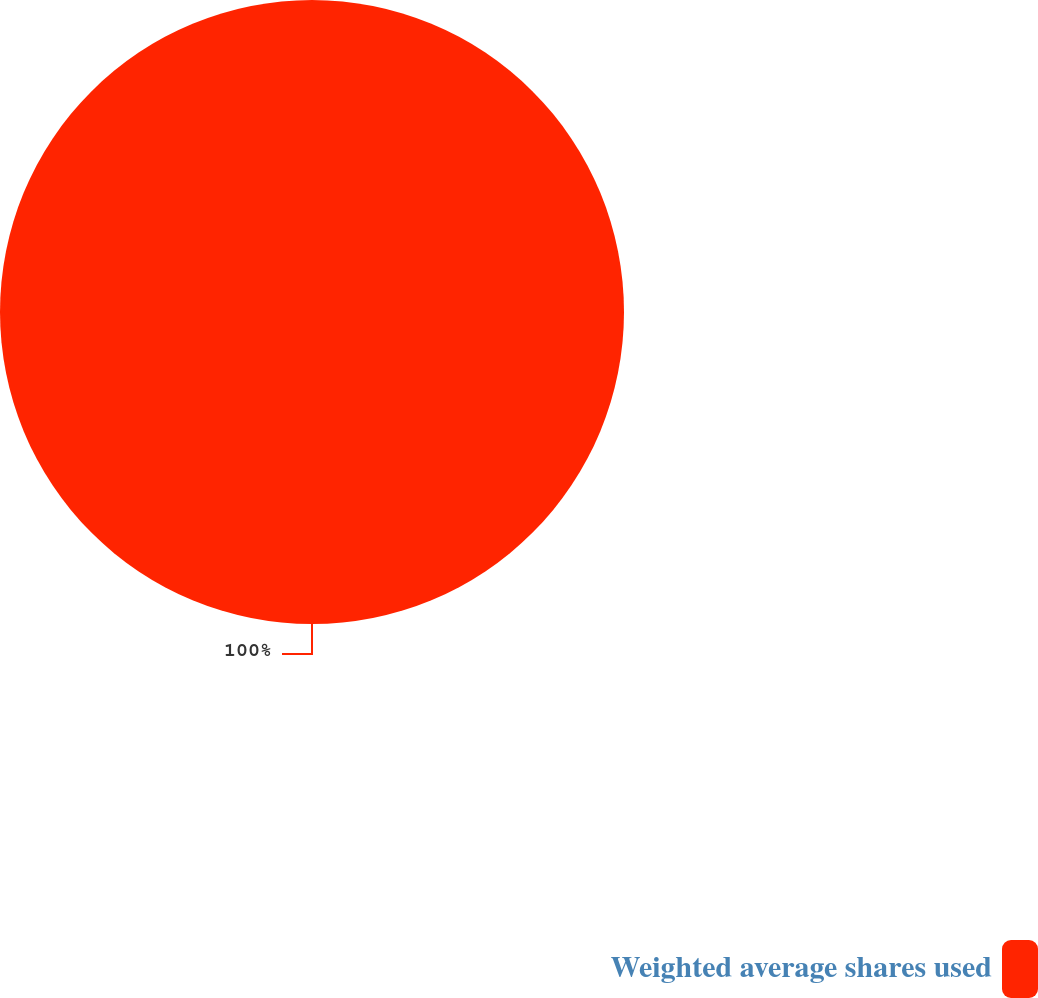Convert chart to OTSL. <chart><loc_0><loc_0><loc_500><loc_500><pie_chart><fcel>Weighted average shares used<nl><fcel>100.0%<nl></chart> 